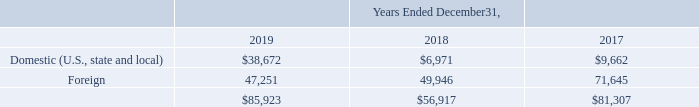Note 20. Income Taxes
The Company’s income before income taxes consisted of the following (in thousands):
What was the total income before income taxes in 2019?
Answer scale should be: thousand. $85,923. What was the  Foreign  income before income taxes in 2018?
Answer scale should be: thousand. 49,946. What are the components under income before income taxes? Domestic (u.s., state and local), foreign. In which year was income before income taxes the largest? $85,923>$81,307>$56,917
Answer: 2019. What was the change in Foreign in 2019 from 2018?
Answer scale should be: thousand. 47,251-49,946
Answer: -2695. What was the percentage change in Foreign income before income taxes in 2019 from 2018?
Answer scale should be: percent. (47,251-49,946)/49,946
Answer: -5.4. 